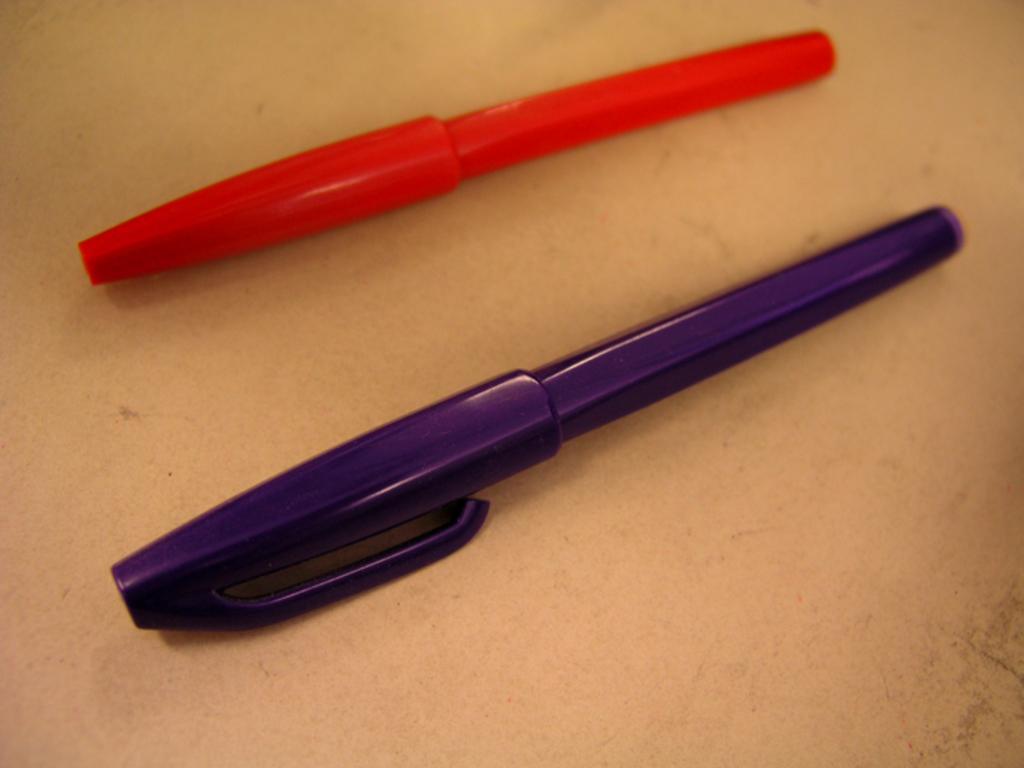In one or two sentences, can you explain what this image depicts? In this image I can see two pens of two different colors. One is in red and another one is in violet. 